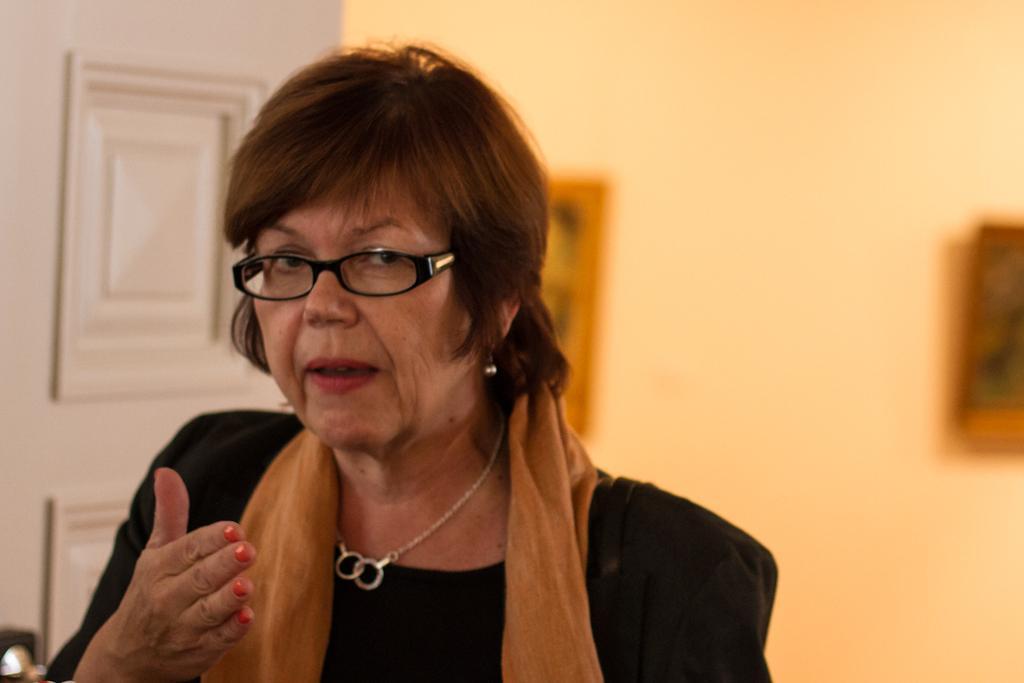Please provide a concise description of this image. In this image a lady is standing wearing a scarf and glasses. In the background there is door. On the wall there are photo frames. 